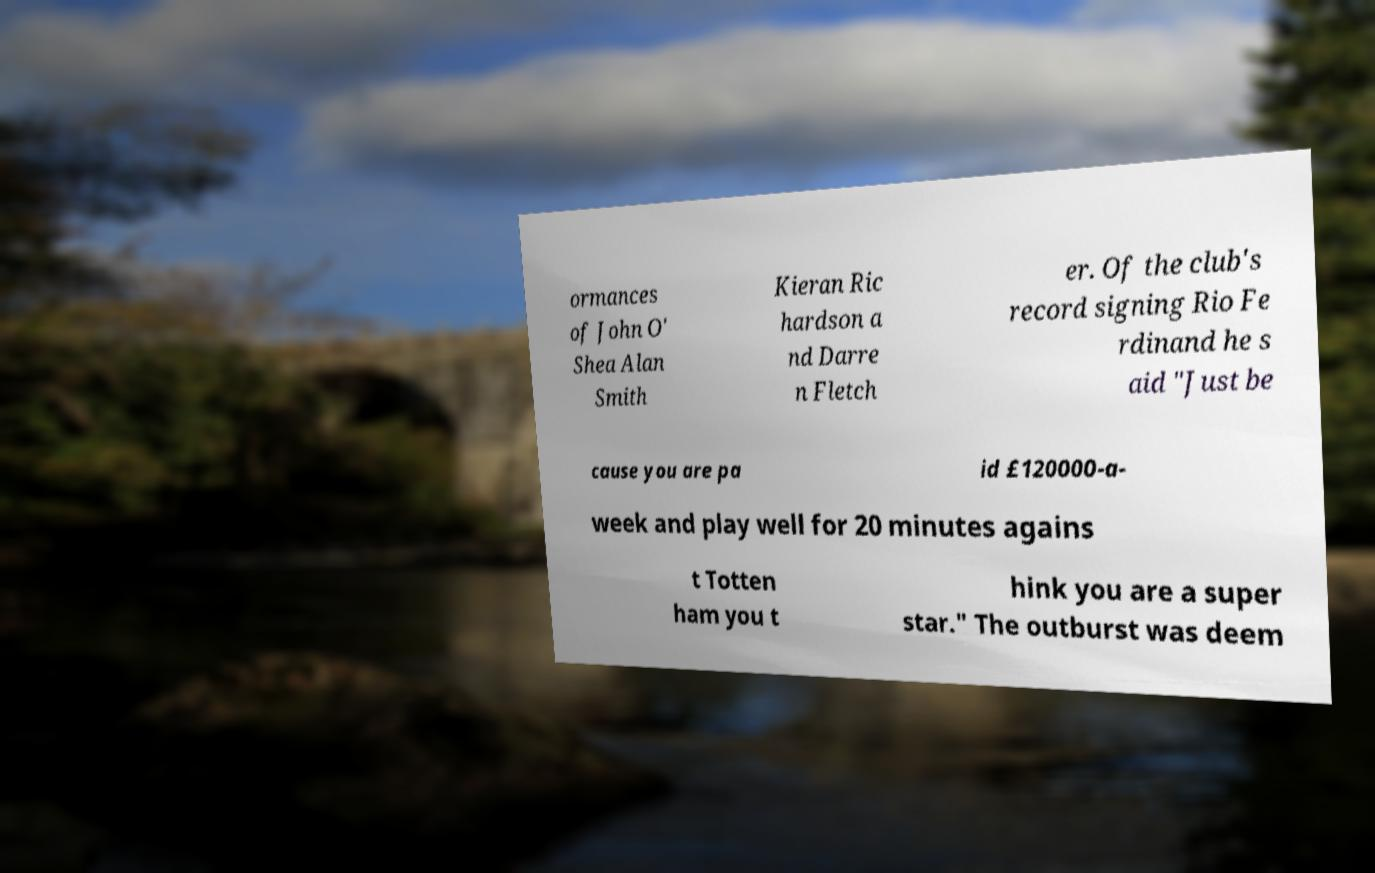Please identify and transcribe the text found in this image. ormances of John O' Shea Alan Smith Kieran Ric hardson a nd Darre n Fletch er. Of the club's record signing Rio Fe rdinand he s aid "Just be cause you are pa id £120000-a- week and play well for 20 minutes agains t Totten ham you t hink you are a super star." The outburst was deem 